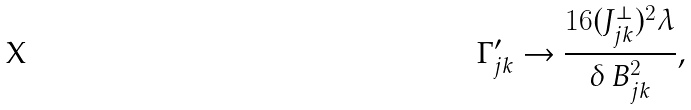Convert formula to latex. <formula><loc_0><loc_0><loc_500><loc_500>\Gamma _ { j k } ^ { \prime } \rightarrow \frac { 1 6 ( J _ { j k } ^ { \perp } ) ^ { 2 } \lambda } { \delta \, B _ { j k } ^ { 2 } } ,</formula> 